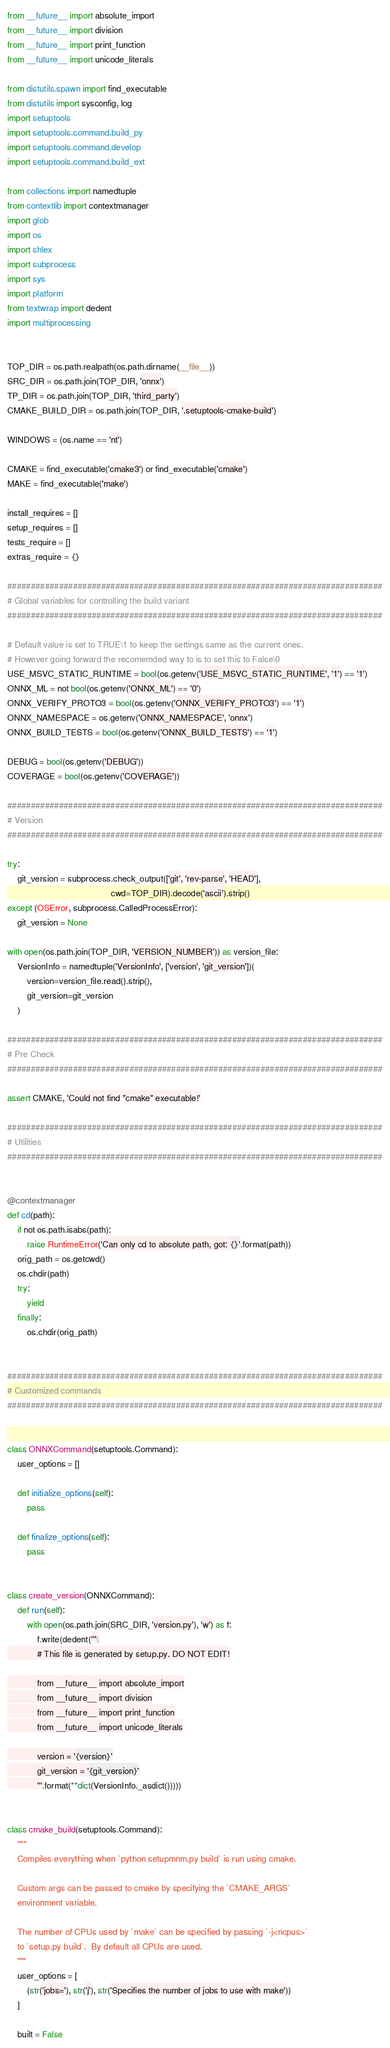Convert code to text. <code><loc_0><loc_0><loc_500><loc_500><_Python_>from __future__ import absolute_import
from __future__ import division
from __future__ import print_function
from __future__ import unicode_literals

from distutils.spawn import find_executable
from distutils import sysconfig, log
import setuptools
import setuptools.command.build_py
import setuptools.command.develop
import setuptools.command.build_ext

from collections import namedtuple
from contextlib import contextmanager
import glob
import os
import shlex
import subprocess
import sys
import platform
from textwrap import dedent
import multiprocessing


TOP_DIR = os.path.realpath(os.path.dirname(__file__))
SRC_DIR = os.path.join(TOP_DIR, 'onnx')
TP_DIR = os.path.join(TOP_DIR, 'third_party')
CMAKE_BUILD_DIR = os.path.join(TOP_DIR, '.setuptools-cmake-build')

WINDOWS = (os.name == 'nt')

CMAKE = find_executable('cmake3') or find_executable('cmake')
MAKE = find_executable('make')

install_requires = []
setup_requires = []
tests_require = []
extras_require = {}

################################################################################
# Global variables for controlling the build variant
################################################################################

# Default value is set to TRUE\1 to keep the settings same as the current ones.
# However going forward the recomemded way to is to set this to False\0
USE_MSVC_STATIC_RUNTIME = bool(os.getenv('USE_MSVC_STATIC_RUNTIME', '1') == '1')
ONNX_ML = not bool(os.getenv('ONNX_ML') == '0')
ONNX_VERIFY_PROTO3 = bool(os.getenv('ONNX_VERIFY_PROTO3') == '1')
ONNX_NAMESPACE = os.getenv('ONNX_NAMESPACE', 'onnx')
ONNX_BUILD_TESTS = bool(os.getenv('ONNX_BUILD_TESTS') == '1')

DEBUG = bool(os.getenv('DEBUG'))
COVERAGE = bool(os.getenv('COVERAGE'))

################################################################################
# Version
################################################################################

try:
    git_version = subprocess.check_output(['git', 'rev-parse', 'HEAD'],
                                          cwd=TOP_DIR).decode('ascii').strip()
except (OSError, subprocess.CalledProcessError):
    git_version = None

with open(os.path.join(TOP_DIR, 'VERSION_NUMBER')) as version_file:
    VersionInfo = namedtuple('VersionInfo', ['version', 'git_version'])(
        version=version_file.read().strip(),
        git_version=git_version
    )

################################################################################
# Pre Check
################################################################################

assert CMAKE, 'Could not find "cmake" executable!'

################################################################################
# Utilities
################################################################################


@contextmanager
def cd(path):
    if not os.path.isabs(path):
        raise RuntimeError('Can only cd to absolute path, got: {}'.format(path))
    orig_path = os.getcwd()
    os.chdir(path)
    try:
        yield
    finally:
        os.chdir(orig_path)


################################################################################
# Customized commands
################################################################################


class ONNXCommand(setuptools.Command):
    user_options = []

    def initialize_options(self):
        pass

    def finalize_options(self):
        pass


class create_version(ONNXCommand):
    def run(self):
        with open(os.path.join(SRC_DIR, 'version.py'), 'w') as f:
            f.write(dedent('''\
            # This file is generated by setup.py. DO NOT EDIT!

            from __future__ import absolute_import
            from __future__ import division
            from __future__ import print_function
            from __future__ import unicode_literals

            version = '{version}'
            git_version = '{git_version}'
            '''.format(**dict(VersionInfo._asdict()))))


class cmake_build(setuptools.Command):
    """
    Compiles everything when `python setupmnm.py build` is run using cmake.

    Custom args can be passed to cmake by specifying the `CMAKE_ARGS`
    environment variable.

    The number of CPUs used by `make` can be specified by passing `-j<ncpus>`
    to `setup.py build`.  By default all CPUs are used.
    """
    user_options = [
        (str('jobs='), str('j'), str('Specifies the number of jobs to use with make'))
    ]

    built = False
</code> 